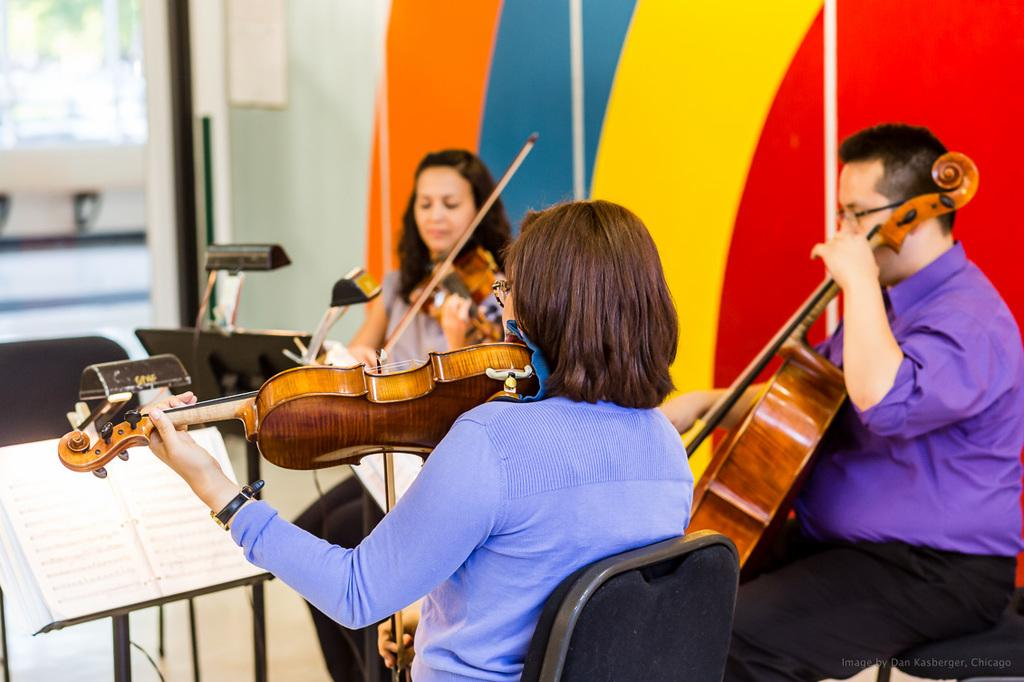What is happening in the image involving a group of people? There is a group of people in the image, and some of them are playing the violin. How are the people positioned in the image? The people are sitting on chairs in the image. What object can be seen in the image related to reading or learning? There is a book in the image. What architectural feature is present in the image? There is a door in the image. What type of advice can be seen written on the door in the image? There is no advice written on the door in the image. 